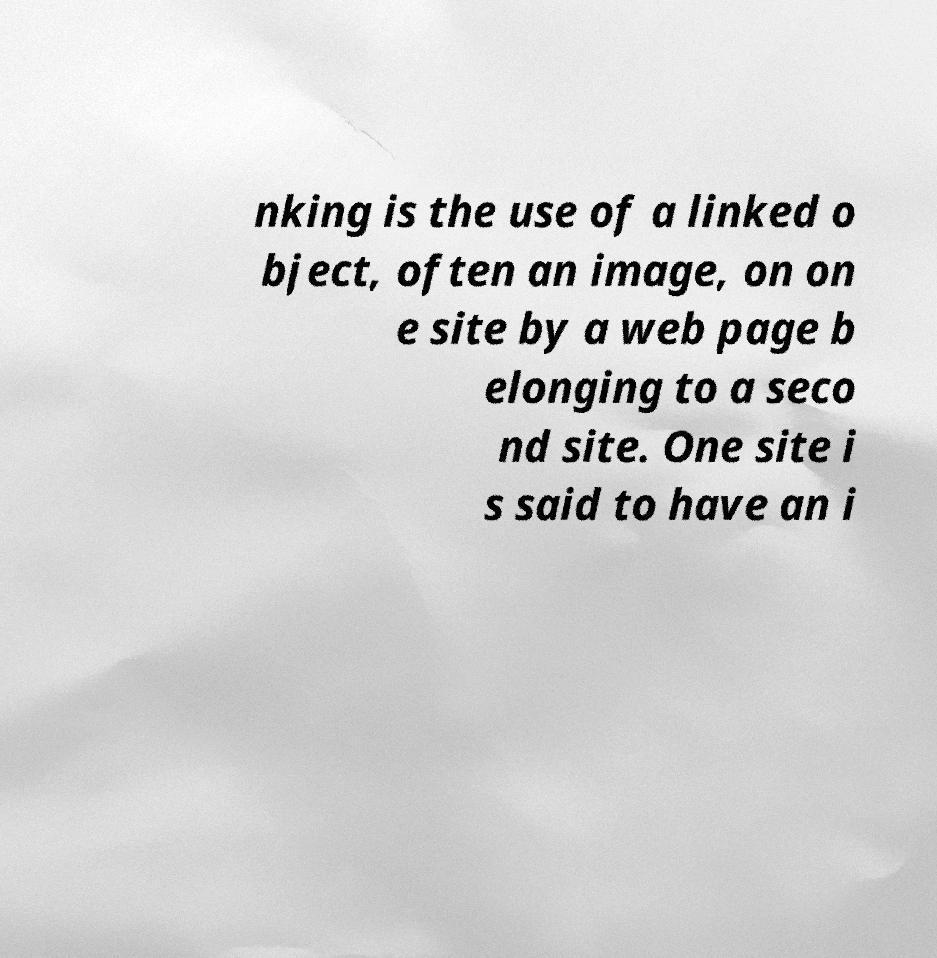Can you accurately transcribe the text from the provided image for me? nking is the use of a linked o bject, often an image, on on e site by a web page b elonging to a seco nd site. One site i s said to have an i 